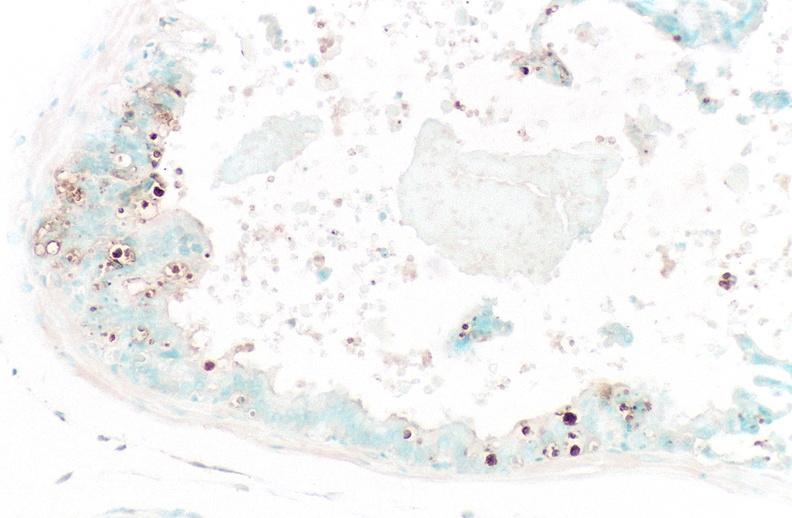what stain?
Answer the question using a single word or phrase. Apoptosis tunel 